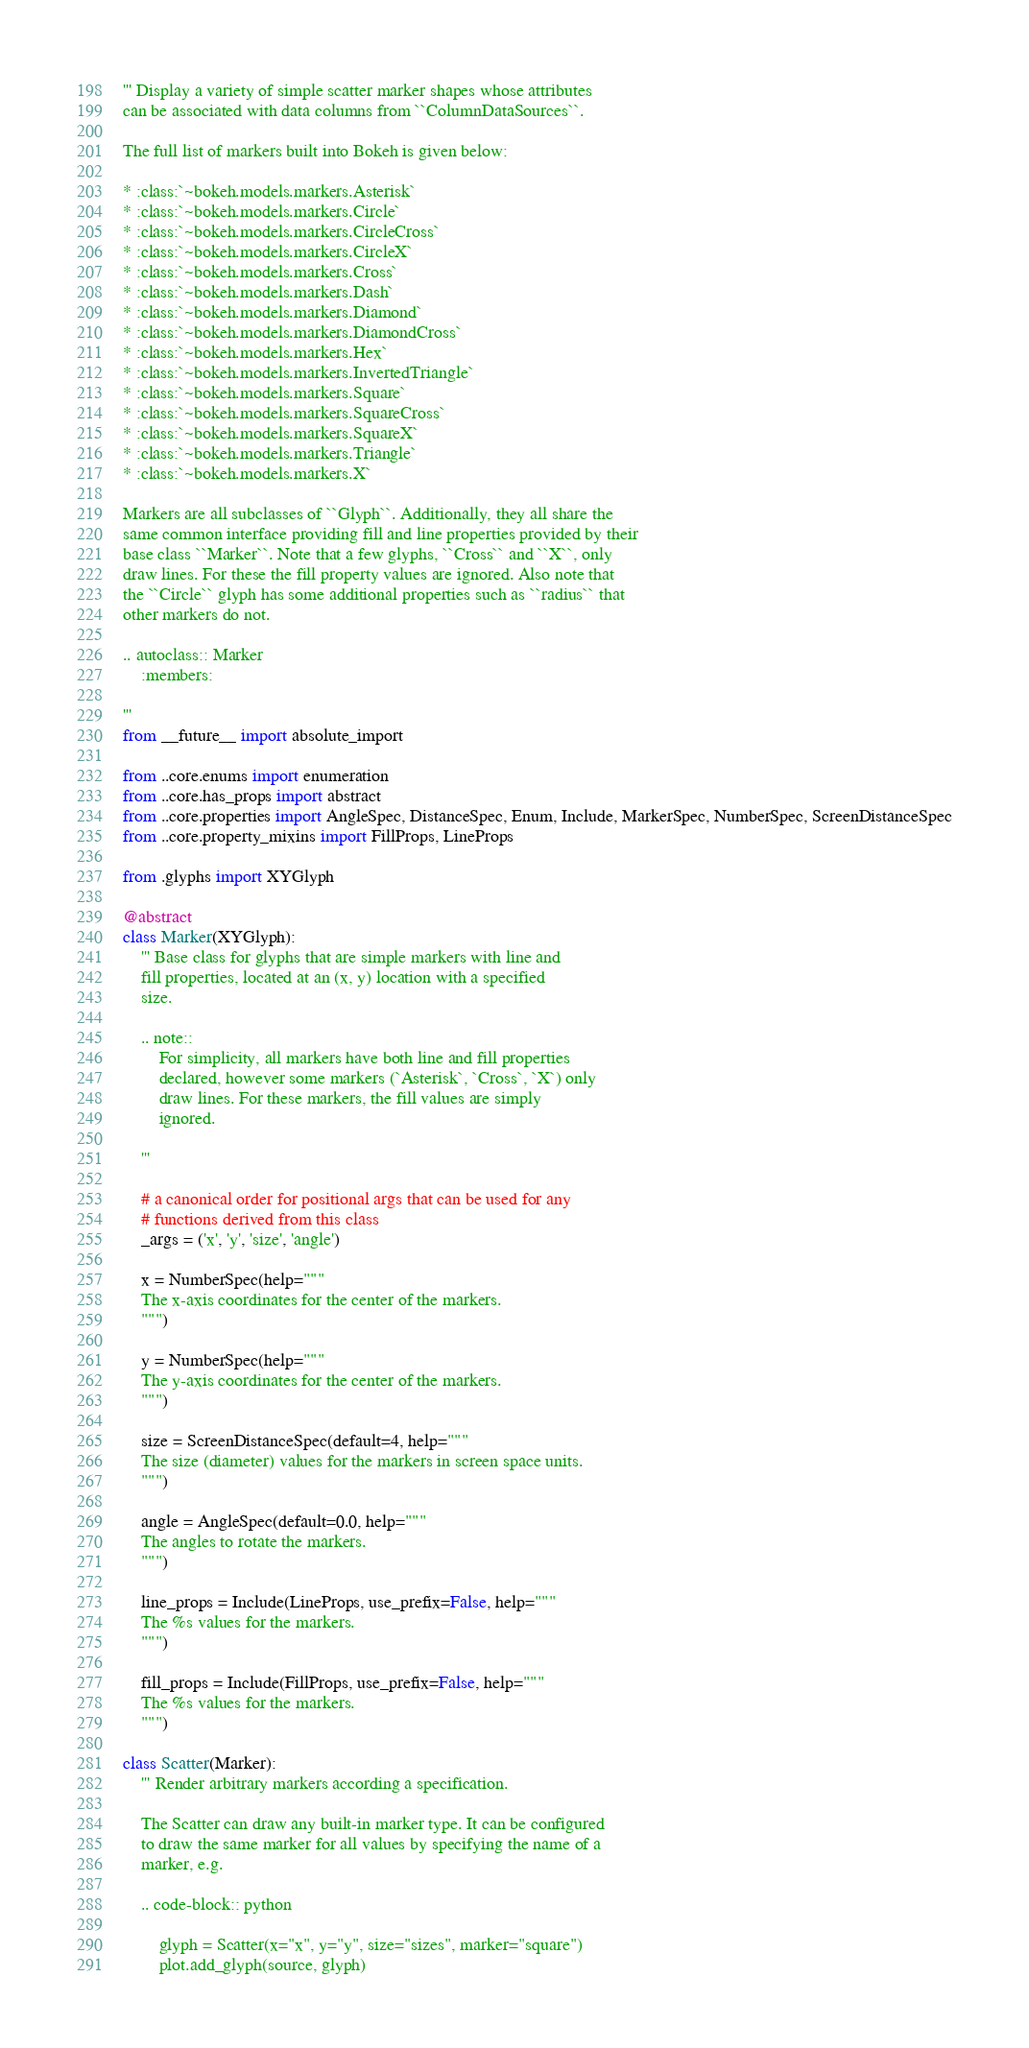Convert code to text. <code><loc_0><loc_0><loc_500><loc_500><_Python_>''' Display a variety of simple scatter marker shapes whose attributes
can be associated with data columns from ``ColumnDataSources``.

The full list of markers built into Bokeh is given below:

* :class:`~bokeh.models.markers.Asterisk`
* :class:`~bokeh.models.markers.Circle`
* :class:`~bokeh.models.markers.CircleCross`
* :class:`~bokeh.models.markers.CircleX`
* :class:`~bokeh.models.markers.Cross`
* :class:`~bokeh.models.markers.Dash`
* :class:`~bokeh.models.markers.Diamond`
* :class:`~bokeh.models.markers.DiamondCross`
* :class:`~bokeh.models.markers.Hex`
* :class:`~bokeh.models.markers.InvertedTriangle`
* :class:`~bokeh.models.markers.Square`
* :class:`~bokeh.models.markers.SquareCross`
* :class:`~bokeh.models.markers.SquareX`
* :class:`~bokeh.models.markers.Triangle`
* :class:`~bokeh.models.markers.X`

Markers are all subclasses of ``Glyph``. Additionally, they all share the
same common interface providing fill and line properties provided by their
base class ``Marker``. Note that a few glyphs, ``Cross`` and ``X``, only
draw lines. For these the fill property values are ignored. Also note that
the ``Circle`` glyph has some additional properties such as ``radius`` that
other markers do not.

.. autoclass:: Marker
    :members:

'''
from __future__ import absolute_import

from ..core.enums import enumeration
from ..core.has_props import abstract
from ..core.properties import AngleSpec, DistanceSpec, Enum, Include, MarkerSpec, NumberSpec, ScreenDistanceSpec
from ..core.property_mixins import FillProps, LineProps

from .glyphs import XYGlyph

@abstract
class Marker(XYGlyph):
    ''' Base class for glyphs that are simple markers with line and
    fill properties, located at an (x, y) location with a specified
    size.

    .. note::
        For simplicity, all markers have both line and fill properties
        declared, however some markers (`Asterisk`, `Cross`, `X`) only
        draw lines. For these markers, the fill values are simply
        ignored.

    '''

    # a canonical order for positional args that can be used for any
    # functions derived from this class
    _args = ('x', 'y', 'size', 'angle')

    x = NumberSpec(help="""
    The x-axis coordinates for the center of the markers.
    """)

    y = NumberSpec(help="""
    The y-axis coordinates for the center of the markers.
    """)

    size = ScreenDistanceSpec(default=4, help="""
    The size (diameter) values for the markers in screen space units.
    """)

    angle = AngleSpec(default=0.0, help="""
    The angles to rotate the markers.
    """)

    line_props = Include(LineProps, use_prefix=False, help="""
    The %s values for the markers.
    """)

    fill_props = Include(FillProps, use_prefix=False, help="""
    The %s values for the markers.
    """)

class Scatter(Marker):
    ''' Render arbitrary markers according a specification.

    The Scatter can draw any built-in marker type. It can be configured
    to draw the same marker for all values by specifying the name of a
    marker, e.g.

    .. code-block:: python

        glyph = Scatter(x="x", y="y", size="sizes", marker="square")
        plot.add_glyph(source, glyph)
</code> 